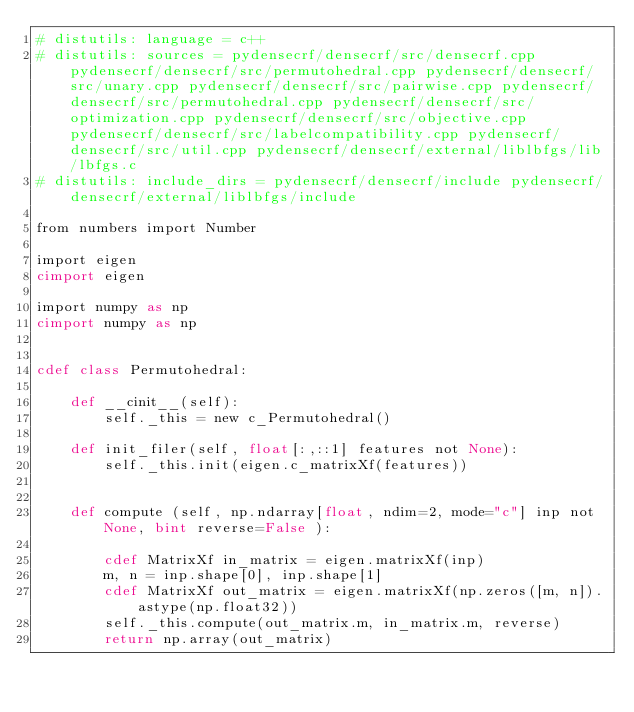<code> <loc_0><loc_0><loc_500><loc_500><_Cython_># distutils: language = c++
# distutils: sources = pydensecrf/densecrf/src/densecrf.cpp pydensecrf/densecrf/src/permutohedral.cpp pydensecrf/densecrf/src/unary.cpp pydensecrf/densecrf/src/pairwise.cpp pydensecrf/densecrf/src/permutohedral.cpp pydensecrf/densecrf/src/optimization.cpp pydensecrf/densecrf/src/objective.cpp pydensecrf/densecrf/src/labelcompatibility.cpp pydensecrf/densecrf/src/util.cpp pydensecrf/densecrf/external/liblbfgs/lib/lbfgs.c
# distutils: include_dirs = pydensecrf/densecrf/include pydensecrf/densecrf/external/liblbfgs/include

from numbers import Number

import eigen
cimport eigen

import numpy as np
cimport numpy as np


cdef class Permutohedral:

    def __cinit__(self):
        self._this = new c_Permutohedral()

    def init_filer(self, float[:,::1] features not None):
        self._this.init(eigen.c_matrixXf(features))


    def compute (self, np.ndarray[float, ndim=2, mode="c"] inp not None, bint reverse=False ):

        cdef MatrixXf in_matrix = eigen.matrixXf(inp)
        m, n = inp.shape[0], inp.shape[1]
        cdef MatrixXf out_matrix = eigen.matrixXf(np.zeros([m, n]).astype(np.float32))
        self._this.compute(out_matrix.m, in_matrix.m, reverse)
        return np.array(out_matrix)
</code> 